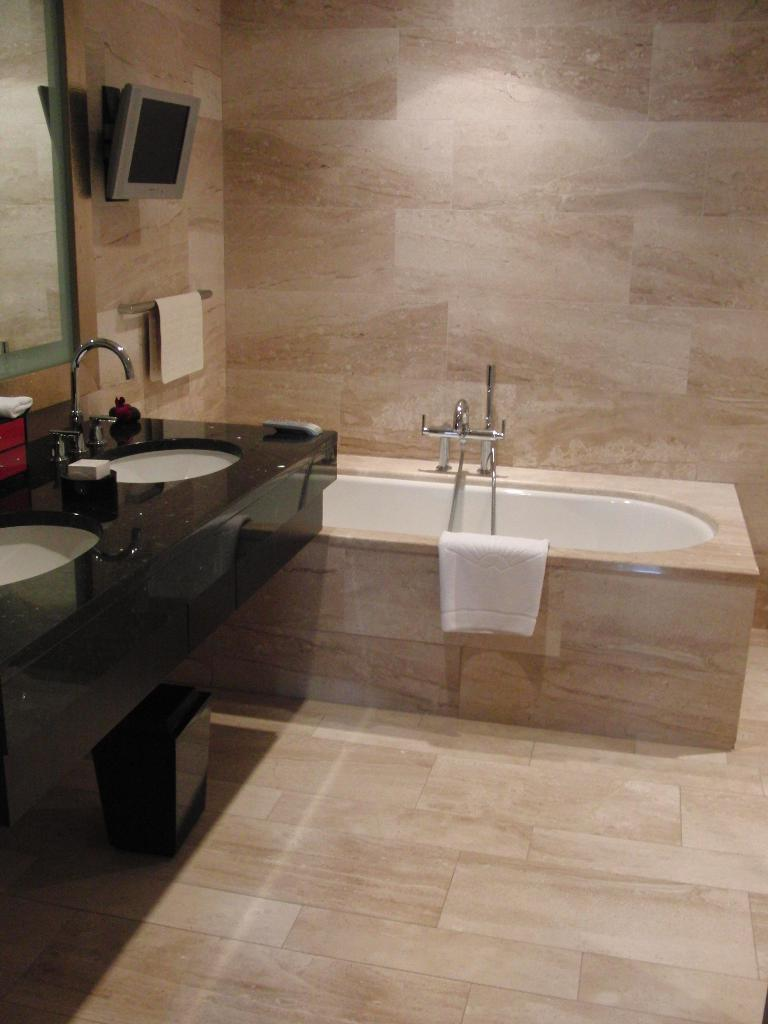What is the main object in the image? There is a bathtub in the image. What item is typically used for drying after using the bathtub? There is a towel in the image. What are the sources of water in the image? There are taps and sinks in the image. What part of the bathroom is used for adjusting the water flow? There is a handle in the image. What device is used for displaying information or images in the image? There is a monitor in the image. What is used for reflecting images in the image? There is a mirror in the image. What is the main structural component in the image? There is a wall in the image. What surface is the bathtub placed on in the image? There is a floor in the image. What type of art can be seen hanging on the wall in the image? There is no art visible on the wall in the image. What is the answer to the question asked in the image? There is no question or answer present in the image. 